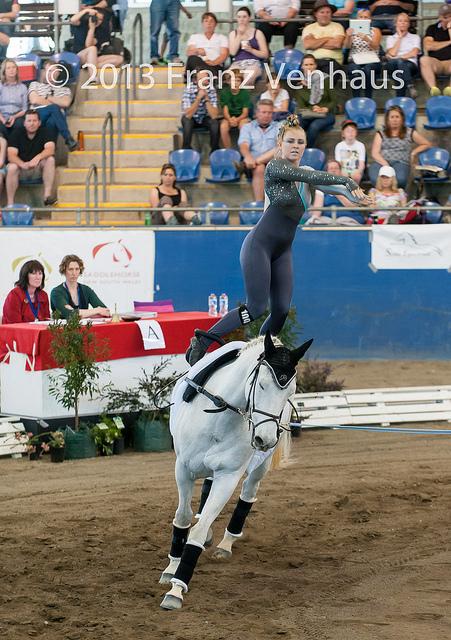What color(s) is the horse?
Keep it brief. White. What sport is this?
Answer briefly. Horseback riding. Is the woman jumping off the horse?
Write a very short answer. No. 